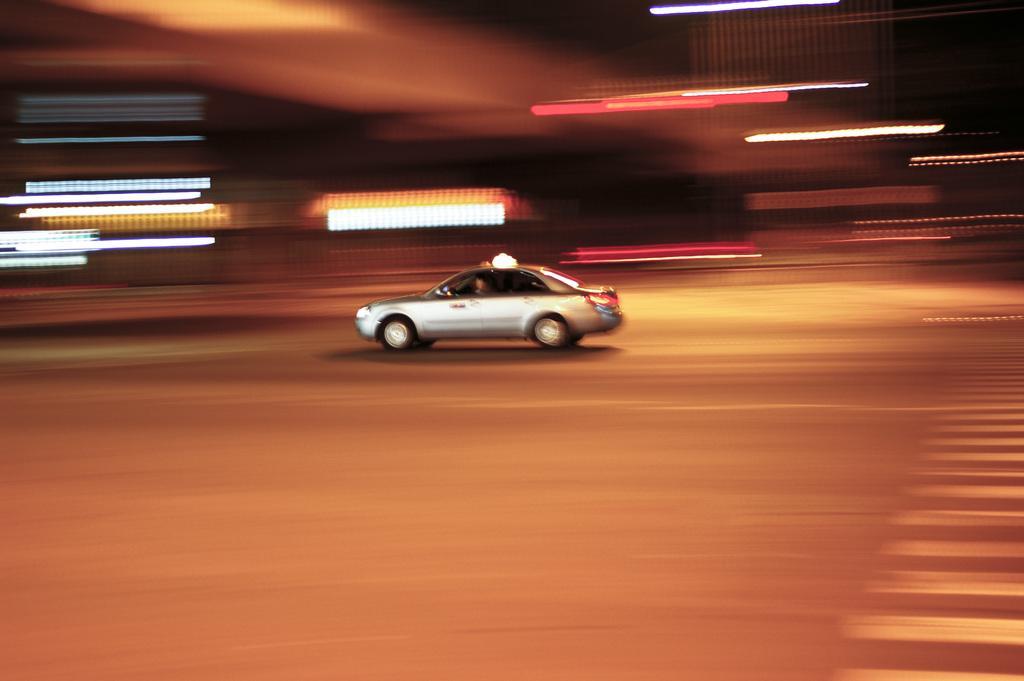In one or two sentences, can you explain what this image depicts? In this picture there is a car in the center of the image. 